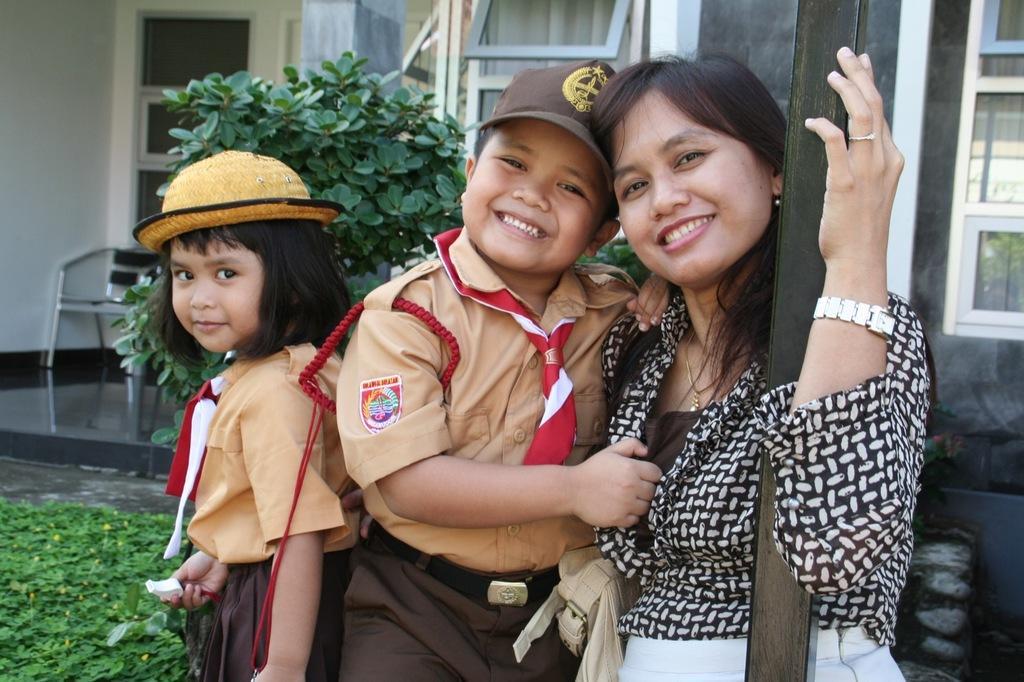Could you give a brief overview of what you see in this image? In the picture I can see two children wearing uniforms and a woman wearing black color dress is standing near the pole and they are smiling. In the background, we can see shrubs, glass windows, a chair and the building. 